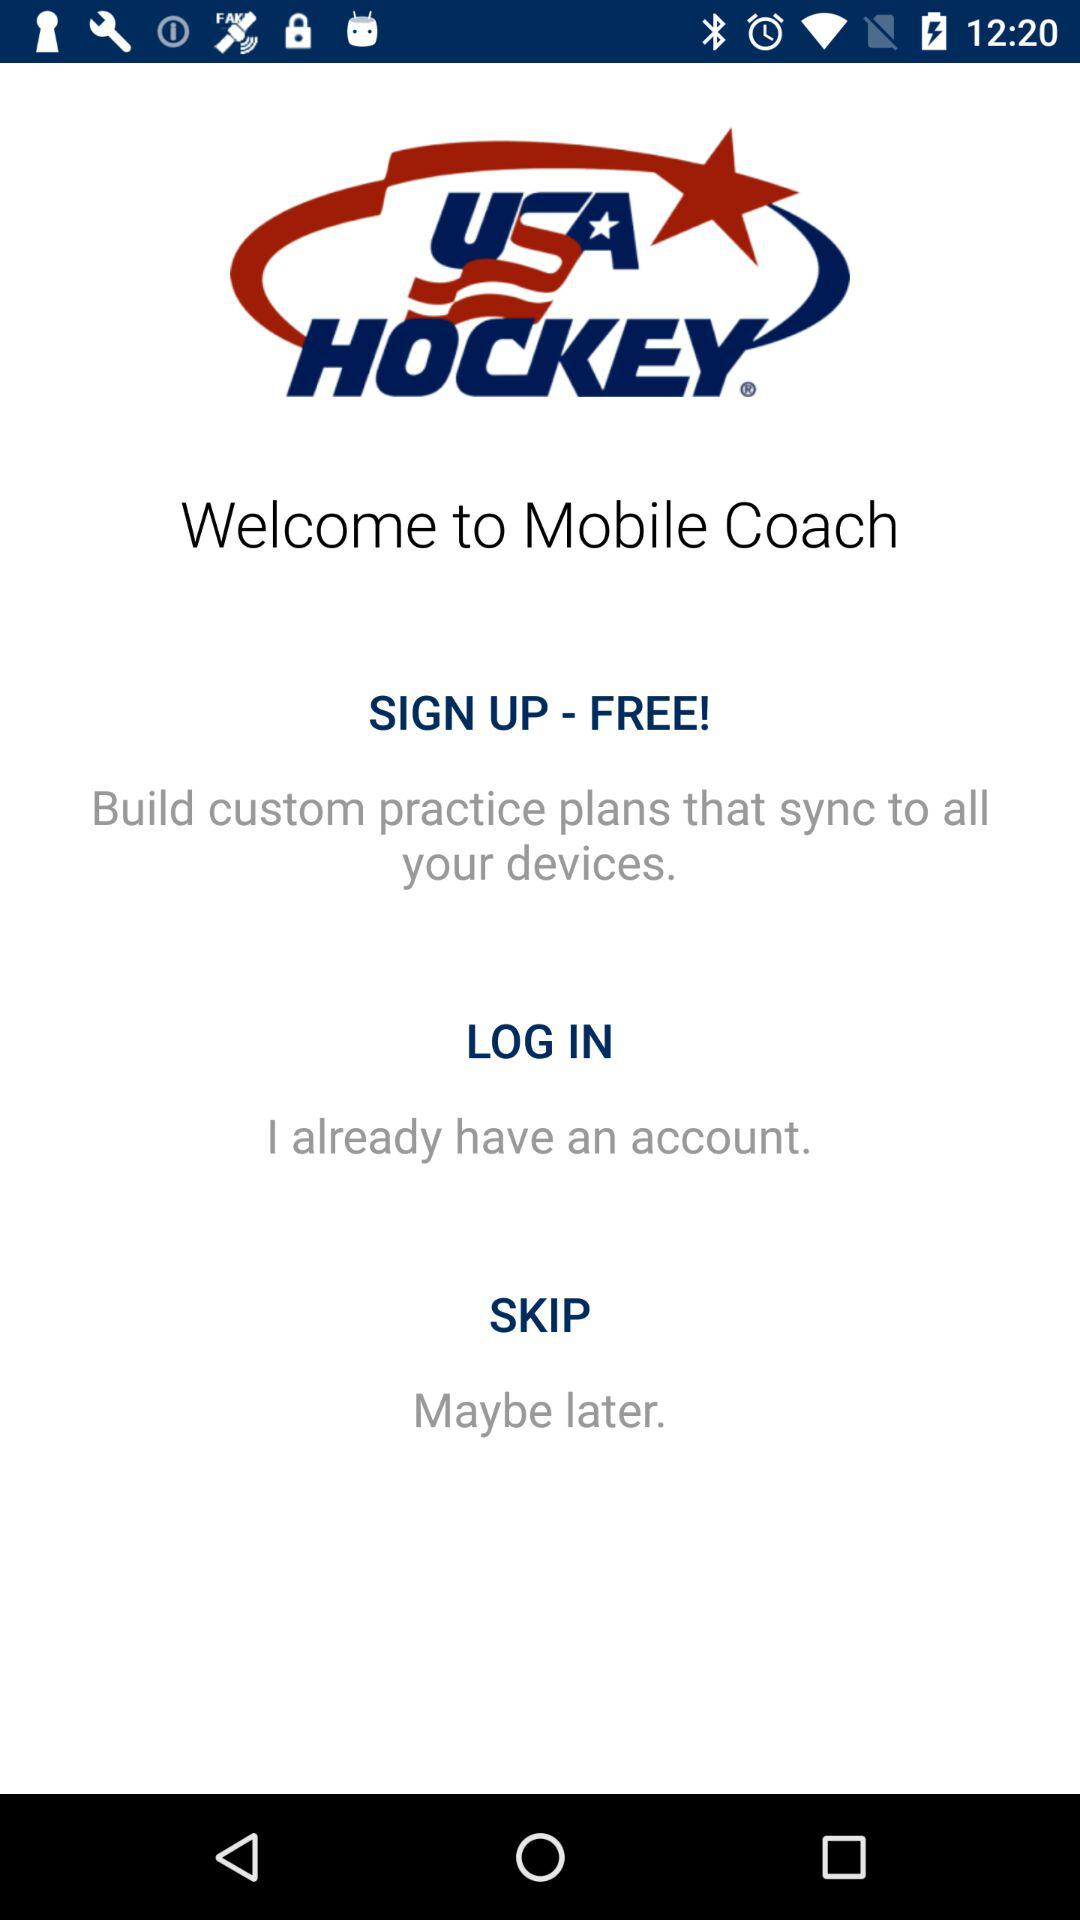What is the application name? The application name is "USA Hockey Mobile Coach". 